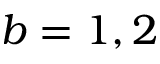<formula> <loc_0><loc_0><loc_500><loc_500>b = 1 , 2</formula> 